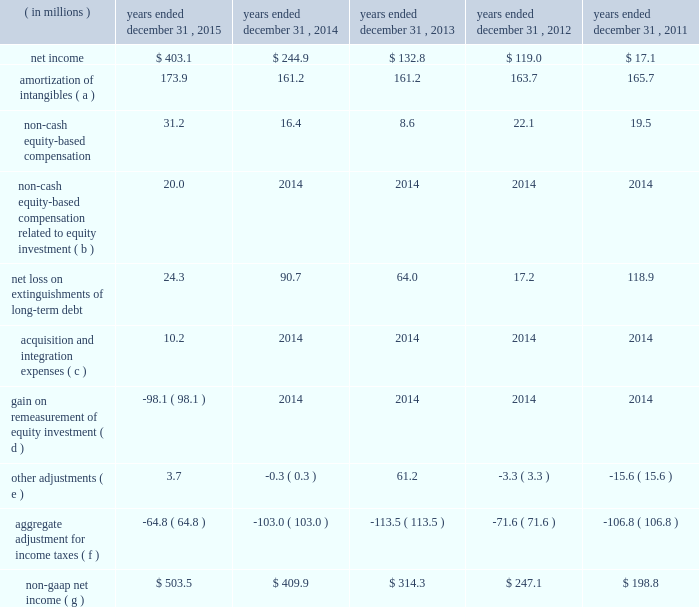Table of contents ( e ) other adjustments primarily include certain historical retention costs , unusual , non-recurring litigation matters , secondary-offering-related expenses and expenses related to the consolidation of office locations north of chicago .
During the year ended december 31 , 2013 , we recorded ipo- and secondary-offering related expenses of $ 75.0 million .
For additional information on the ipo- and secondary-offering related expenses , see note 10 ( stockholder 2019s equity ) to the accompanying consolidated financial statements .
( f ) includes the impact of consolidating five months for the year ended december 31 , 2015 of kelway 2019s financial results .
( 4 ) non-gaap net income excludes , among other things , charges related to the amortization of acquisition-related intangible assets , non-cash equity-based compensation , acquisition and integration expenses , and gains and losses from the extinguishment of long-term debt .
Non-gaap net income is considered a non-gaap financial measure .
Generally , a non-gaap financial measure is a numerical measure of a company 2019s performance , financial position or cash flows that either excludes or includes amounts that are not normally included or excluded in the most directly comparable measure calculated and presented in accordance with gaap .
Non-gaap measures used by us may differ from similar measures used by other companies , even when similar terms are used to identify such measures .
We believe that non-gaap net income provides meaningful information regarding our operating performance and cash flows including our ability to meet our future debt service , capital expenditures and working capital requirements .
The following unaudited table sets forth a reconciliation of net income to non-gaap net income for the periods presented: .
Acquisition and integration expenses ( c ) 10.2 2014 2014 2014 2014 gain on remeasurement of equity investment ( d ) ( 98.1 ) 2014 2014 2014 2014 other adjustments ( e ) 3.7 ( 0.3 ) 61.2 ( 3.3 ) ( 15.6 ) aggregate adjustment for income taxes ( f ) ( 64.8 ) ( 103.0 ) ( 113.5 ) ( 71.6 ) ( 106.8 ) non-gaap net income ( g ) $ 503.5 $ 409.9 $ 314.3 $ 247.1 $ 198.8 ( a ) includes amortization expense for acquisition-related intangible assets , primarily customer relationships , customer contracts and trade names .
( b ) represents our 35% ( 35 % ) share of an expense related to certain equity awards granted by one of the sellers to kelway coworkers in july 2015 prior to our acquisition of kelway .
( c ) primarily includes expenses related to the acquisition of kelway .
( d ) represents the gain resulting from the remeasurement of our previously held 35% ( 35 % ) equity investment to fair value upon the completion of the acquisition of kelway .
( e ) primarily includes expenses related to the consolidation of office locations north of chicago and secondary- offering-related expenses .
Amount in 2013 primarily relates to ipo- and secondary-offering related expenses .
( f ) based on a normalized effective tax rate of 38.0% ( 38.0 % ) ( 39.0% ( 39.0 % ) prior to the kelway acquisition ) , except for the non- cash equity-based compensation from our equity investment and the gain resulting from the remeasurement of our previously held 35% ( 35 % ) equity investment to fair value upon the completion of the acquisition of kelway , which were tax effected at a rate of 35.4% ( 35.4 % ) .
The aggregate adjustment for income taxes also includes a $ 4.0 million deferred tax benefit recorded during the three months and year ended december 31 , 2015 as a result of a tax rate reduction in the united kingdom and additional tax expense during the year ended december 31 , 2015 of $ 3.3 million as a result of recording withholding tax on the unremitted earnings of our canadian subsidiary .
Additionally , note that certain acquisition costs are non-deductible. .
What would 2013 non-gaap net income have been ( millions ) without the stock issuance expenses? 
Computations: (314.3 + 75.0)
Answer: 389.3. 